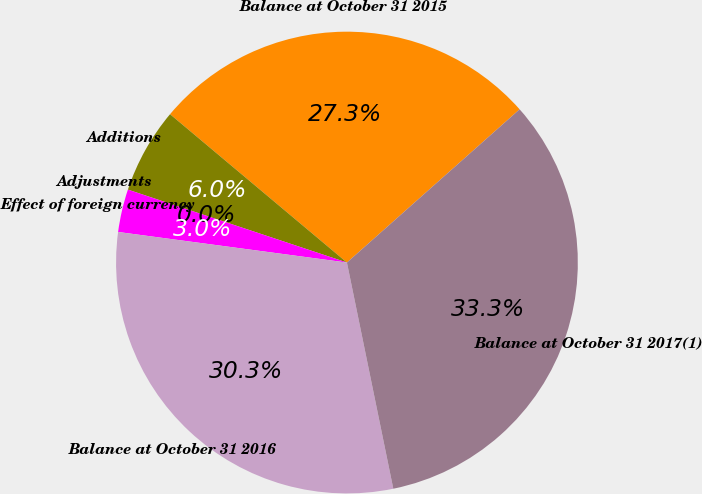Convert chart to OTSL. <chart><loc_0><loc_0><loc_500><loc_500><pie_chart><fcel>Balance at October 31 2015<fcel>Additions<fcel>Adjustments<fcel>Effect of foreign currency<fcel>Balance at October 31 2016<fcel>Balance at October 31 2017(1)<nl><fcel>27.34%<fcel>5.99%<fcel>0.0%<fcel>3.0%<fcel>30.33%<fcel>33.33%<nl></chart> 